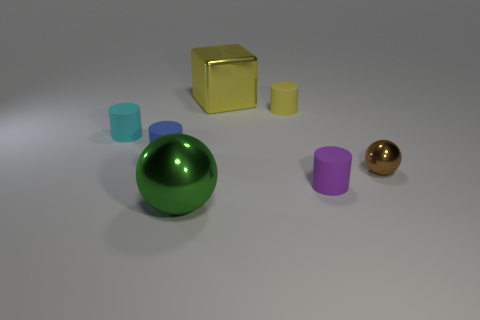Is there a tiny matte thing that has the same color as the shiny block?
Your answer should be compact. Yes. What number of objects are big metallic objects that are in front of the small brown thing or yellow objects?
Provide a succinct answer. 3. What number of other things are the same size as the yellow cube?
Your answer should be compact. 1. What is the yellow thing that is in front of the big thing right of the metal thing that is on the left side of the big yellow shiny cube made of?
Provide a short and direct response. Rubber. How many cubes are tiny cyan matte things or matte objects?
Keep it short and to the point. 0. Is there anything else that is the same shape as the large yellow metallic thing?
Offer a very short reply. No. Are there more purple rubber objects that are in front of the blue cylinder than tiny matte objects that are behind the small yellow matte cylinder?
Offer a terse response. Yes. What number of small objects are to the right of the metal thing behind the tiny brown metal thing?
Your answer should be very brief. 3. What number of things are either tiny blue rubber cylinders or small purple balls?
Ensure brevity in your answer.  1. Does the green thing have the same shape as the small brown metallic thing?
Provide a short and direct response. Yes. 